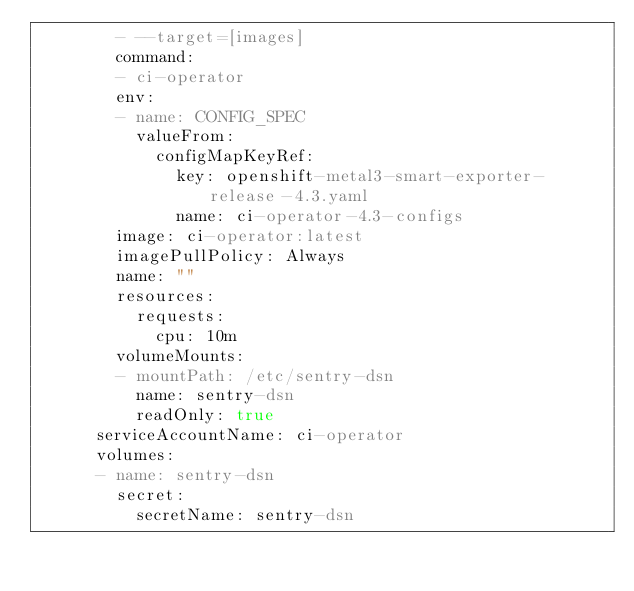<code> <loc_0><loc_0><loc_500><loc_500><_YAML_>        - --target=[images]
        command:
        - ci-operator
        env:
        - name: CONFIG_SPEC
          valueFrom:
            configMapKeyRef:
              key: openshift-metal3-smart-exporter-release-4.3.yaml
              name: ci-operator-4.3-configs
        image: ci-operator:latest
        imagePullPolicy: Always
        name: ""
        resources:
          requests:
            cpu: 10m
        volumeMounts:
        - mountPath: /etc/sentry-dsn
          name: sentry-dsn
          readOnly: true
      serviceAccountName: ci-operator
      volumes:
      - name: sentry-dsn
        secret:
          secretName: sentry-dsn
</code> 